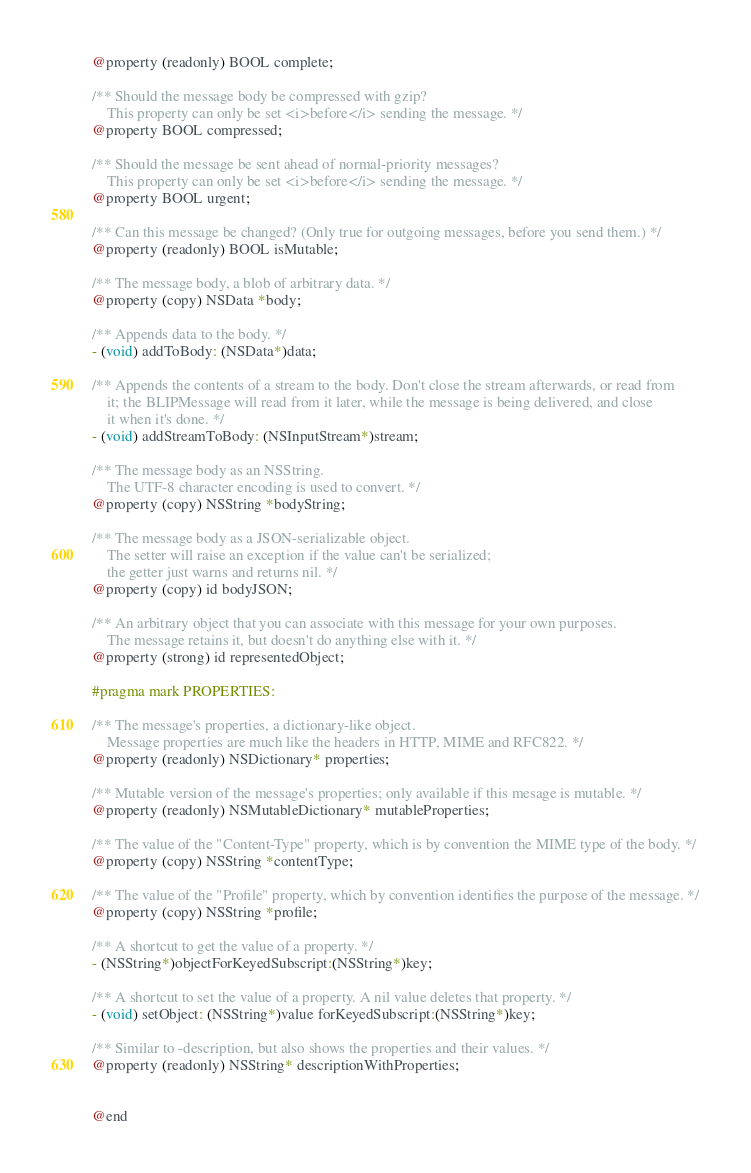Convert code to text. <code><loc_0><loc_0><loc_500><loc_500><_C_>@property (readonly) BOOL complete;

/** Should the message body be compressed with gzip?
    This property can only be set <i>before</i> sending the message. */
@property BOOL compressed;

/** Should the message be sent ahead of normal-priority messages?
    This property can only be set <i>before</i> sending the message. */
@property BOOL urgent;

/** Can this message be changed? (Only true for outgoing messages, before you send them.) */
@property (readonly) BOOL isMutable;

/** The message body, a blob of arbitrary data. */
@property (copy) NSData *body;

/** Appends data to the body. */
- (void) addToBody: (NSData*)data;

/** Appends the contents of a stream to the body. Don't close the stream afterwards, or read from
    it; the BLIPMessage will read from it later, while the message is being delivered, and close
    it when it's done. */
- (void) addStreamToBody: (NSInputStream*)stream;

/** The message body as an NSString.
    The UTF-8 character encoding is used to convert. */
@property (copy) NSString *bodyString;

/** The message body as a JSON-serializable object.
    The setter will raise an exception if the value can't be serialized;
    the getter just warns and returns nil. */
@property (copy) id bodyJSON;

/** An arbitrary object that you can associate with this message for your own purposes.
    The message retains it, but doesn't do anything else with it. */
@property (strong) id representedObject;

#pragma mark PROPERTIES:

/** The message's properties, a dictionary-like object.
    Message properties are much like the headers in HTTP, MIME and RFC822. */
@property (readonly) NSDictionary* properties;

/** Mutable version of the message's properties; only available if this mesage is mutable. */
@property (readonly) NSMutableDictionary* mutableProperties;

/** The value of the "Content-Type" property, which is by convention the MIME type of the body. */
@property (copy) NSString *contentType;

/** The value of the "Profile" property, which by convention identifies the purpose of the message. */
@property (copy) NSString *profile;

/** A shortcut to get the value of a property. */
- (NSString*)objectForKeyedSubscript:(NSString*)key;

/** A shortcut to set the value of a property. A nil value deletes that property. */
- (void) setObject: (NSString*)value forKeyedSubscript:(NSString*)key;

/** Similar to -description, but also shows the properties and their values. */
@property (readonly) NSString* descriptionWithProperties;


@end
</code> 